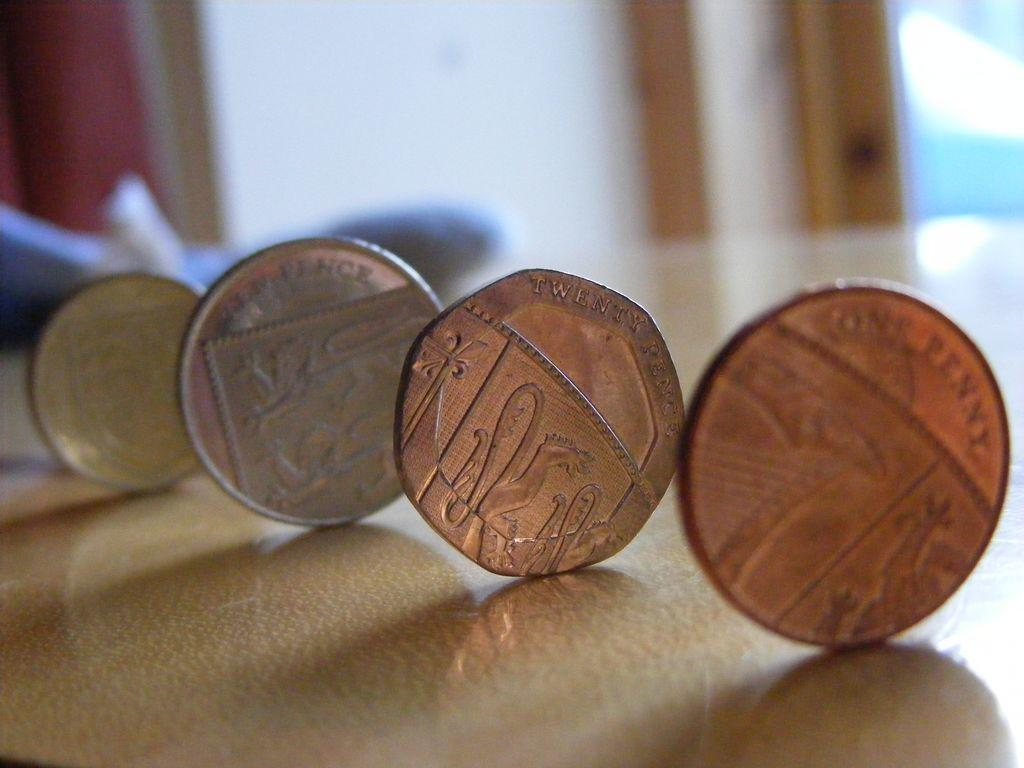Provide a one-sentence caption for the provided image. a series of four coins, the first one reading one penny and the second reading twenty pence. 